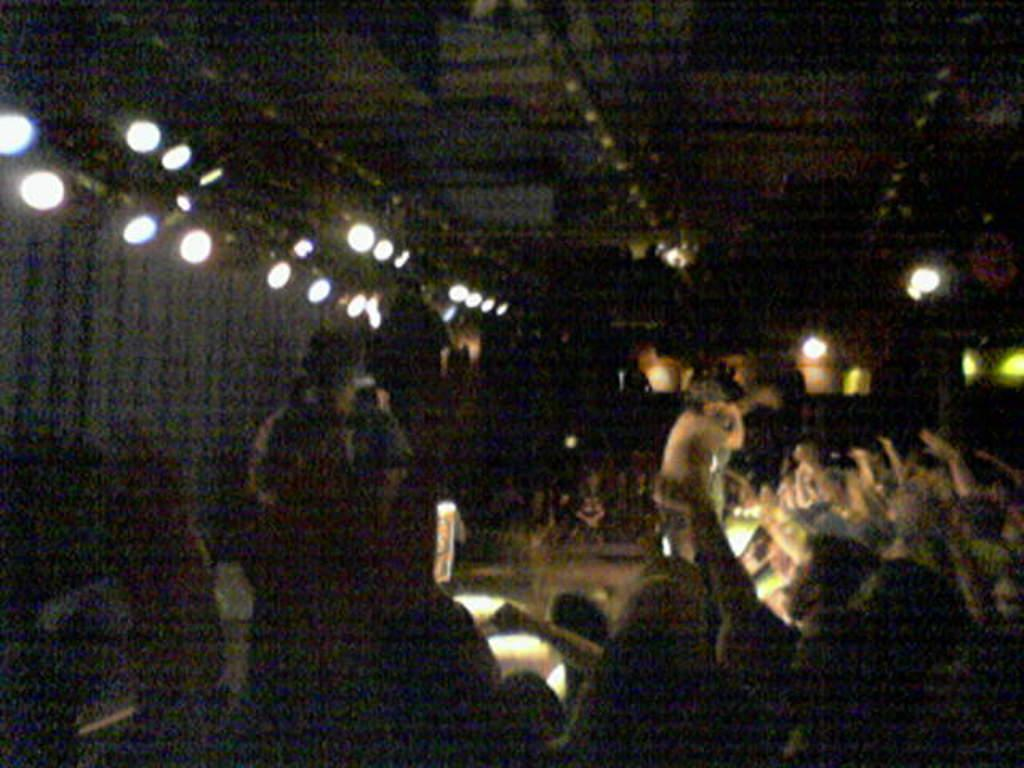What is the general arrangement of people in the image? There is a crowd sitting in the image. Is there anyone standing among the seated crowd? Yes, there is a person standing in the center of the image. What can be seen at the top of the image? There are lights visible at the top of the image. What is visible in the background of the image? There is a wall in the background of the image. What type of machine is being operated by the cat in the image? There is no cat present in the image, and therefore no machine being operated by a cat. 